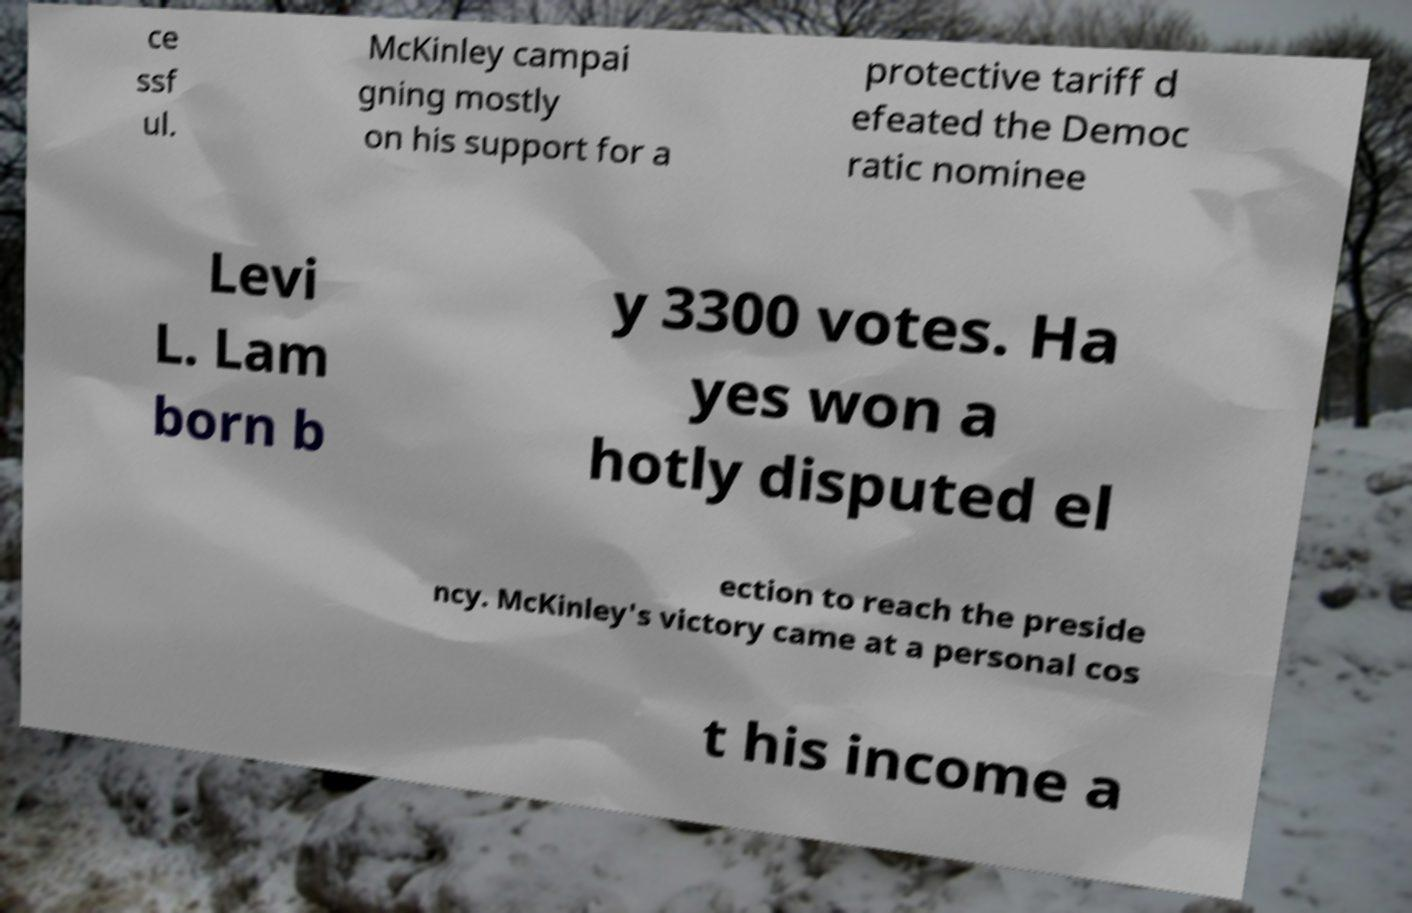I need the written content from this picture converted into text. Can you do that? ce ssf ul. McKinley campai gning mostly on his support for a protective tariff d efeated the Democ ratic nominee Levi L. Lam born b y 3300 votes. Ha yes won a hotly disputed el ection to reach the preside ncy. McKinley's victory came at a personal cos t his income a 